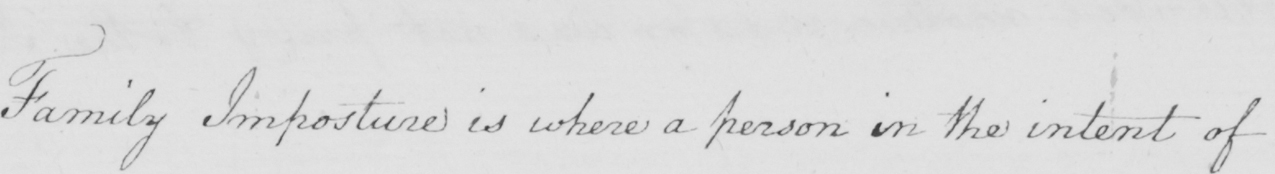Please transcribe the handwritten text in this image. Family Imposture is where a person in the intent of 